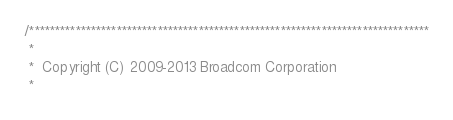Convert code to text. <code><loc_0><loc_0><loc_500><loc_500><_C_>/******************************************************************************
 *
 *  Copyright (C) 2009-2013 Broadcom Corporation
 *</code> 